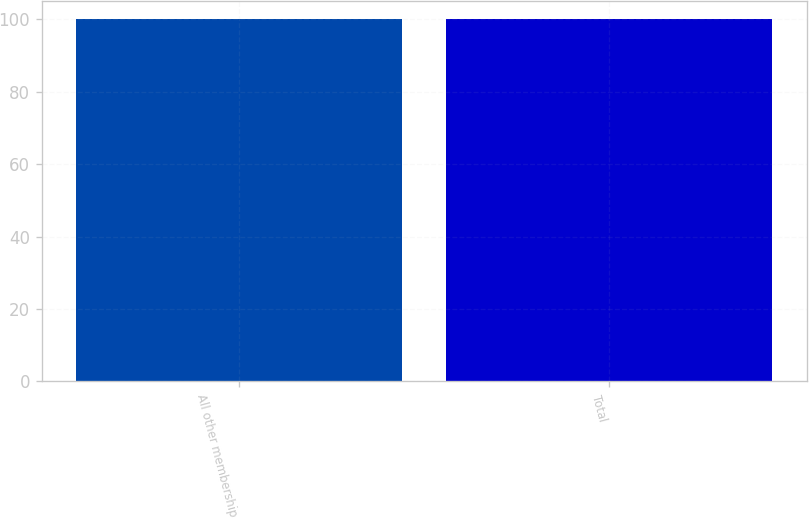Convert chart to OTSL. <chart><loc_0><loc_0><loc_500><loc_500><bar_chart><fcel>All other membership<fcel>Total<nl><fcel>100<fcel>100.1<nl></chart> 